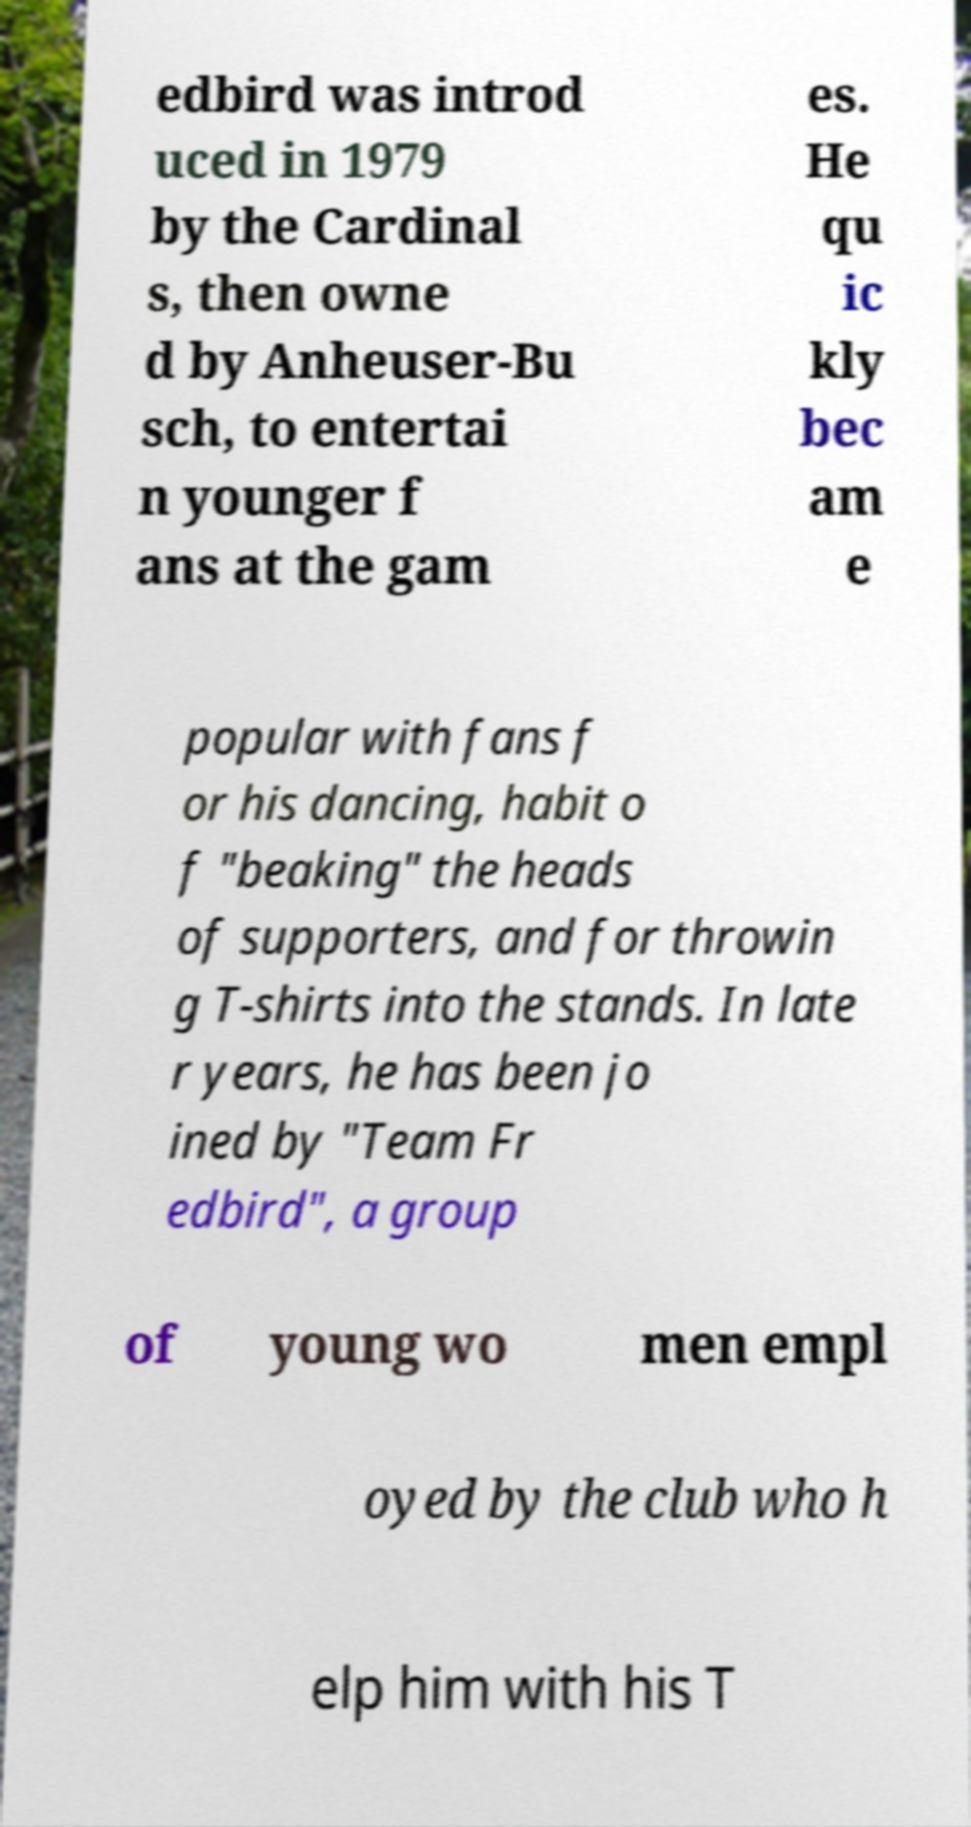Please read and relay the text visible in this image. What does it say? edbird was introd uced in 1979 by the Cardinal s, then owne d by Anheuser-Bu sch, to entertai n younger f ans at the gam es. He qu ic kly bec am e popular with fans f or his dancing, habit o f "beaking" the heads of supporters, and for throwin g T-shirts into the stands. In late r years, he has been jo ined by "Team Fr edbird", a group of young wo men empl oyed by the club who h elp him with his T 